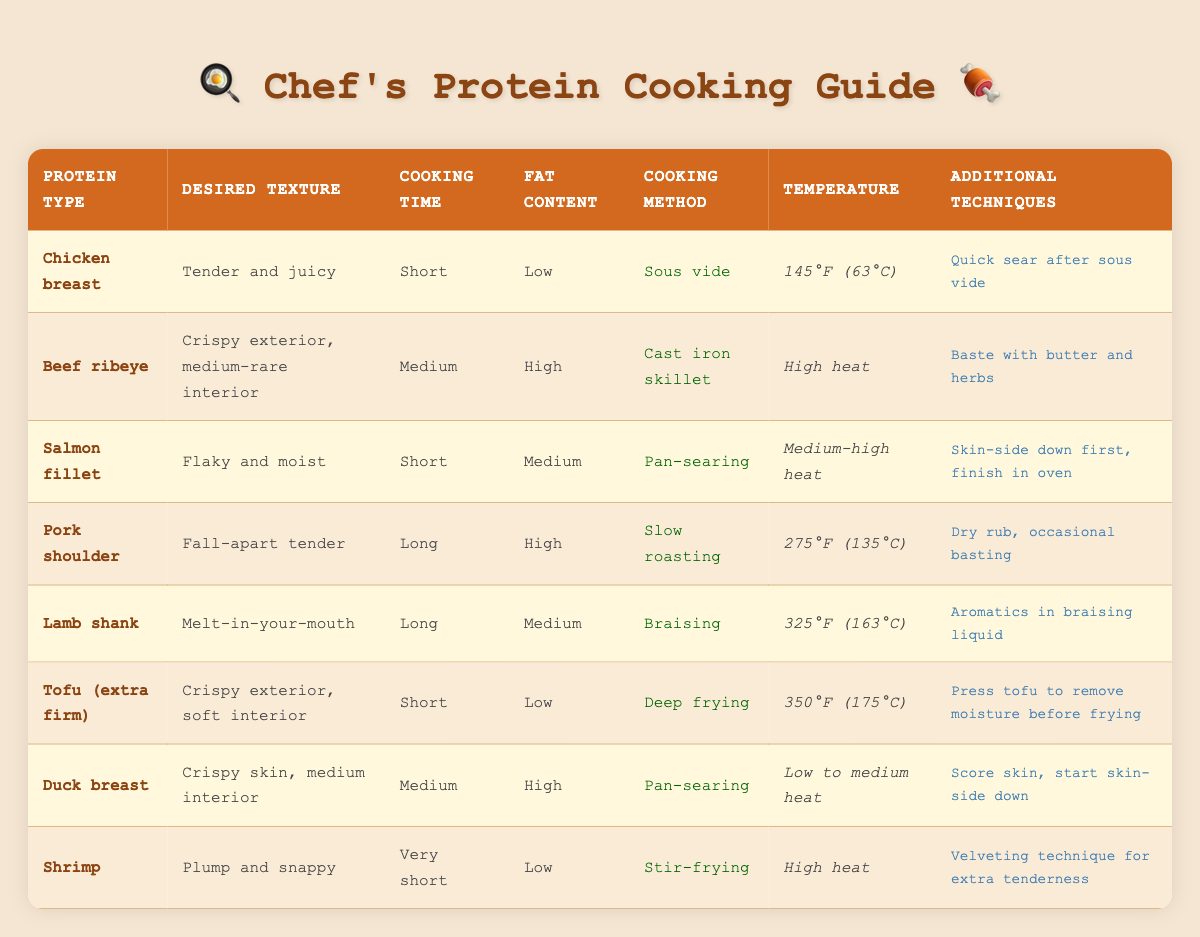What cooking method is recommended for chicken breast to achieve a tender and juicy texture? The table indicates that the cooking method for chicken breast to achieve a tender and juicy texture is sous vide.
Answer: Sous vide What is the temperature for cooking salmon fillet? Referring to the table, the temperature for cooking salmon fillet is set at medium-high heat.
Answer: Medium-high heat Is the fat content of duck breast high? Looking at the table, the fat content for duck breast is categorized as high.
Answer: Yes Which protein type requires a long cooking time to achieve a fall-apart tender texture? According to the table, pork shoulder requires a long cooking time to achieve a fall-apart tender texture.
Answer: Pork shoulder What additional technique should be applied when cooking shrimp? The table specifies that for shrimp, the additional technique to apply is the velveting technique for extra tenderness.
Answer: Velveting technique What is the difference in cooking time between chicken breast and pork shoulder? Chicken breast requires a short cooking time, while pork shoulder requires a long cooking time. The difference is thus between short and long.
Answer: Long (pork shoulder) - Short (chicken breast) How many proteins listed can be cooked using a short cooking time? From the table, three proteins can be cooked in a short time: chicken breast, salmon fillet, and tofu.
Answer: Three Which protein has both a high fat content and requires medium cooking time? The table shows that beef ribeye is the protein with high fat content that also requires medium cooking time.
Answer: Beef ribeye If you want a crispy exterior and soft interior, which protein type should you choose? According to the table, the protein type that achieves a crispy exterior and soft interior is extra firm tofu.
Answer: Tofu (extra firm) What cooking method and temperature should be used for lamb shank to achieve its desired texture? For lamb shank, the cooking method is braising, and the temperature is set at 325°F (163°C) to achieve a melt-in-your-mouth texture.
Answer: Braising at 325°F (163°C) 